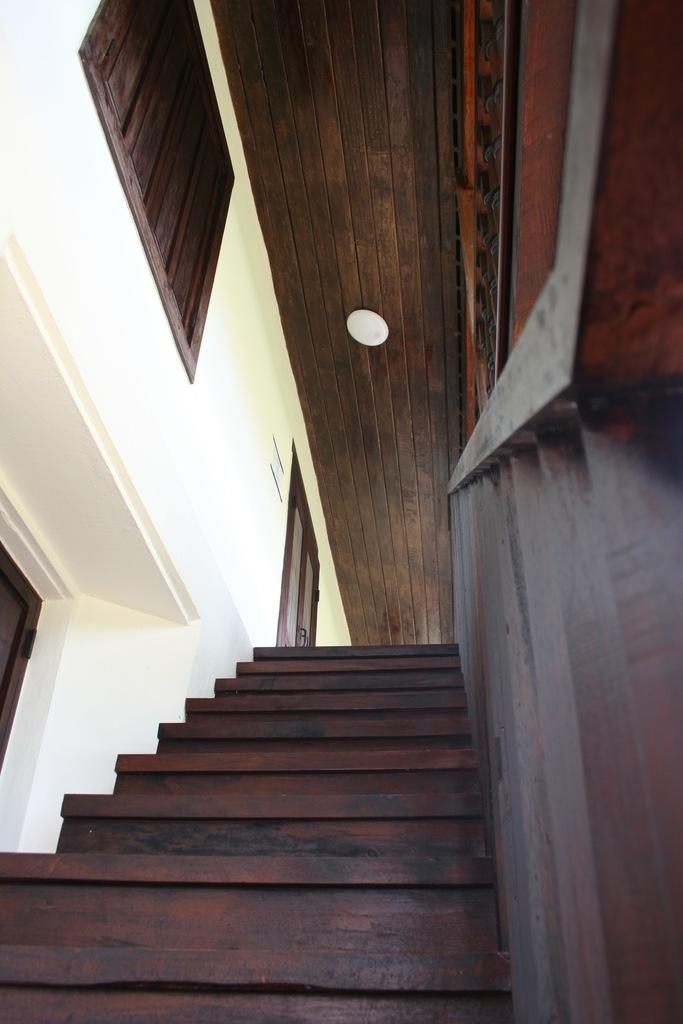What type of structure is present in the image? There is a staircase in the image. What material is used for the railing on the staircase? The railing on the staircase is made of wood. What is visible above the staircase in the image? There is a roof in the image. What surrounds the staircase in the image? There are walls in the image. What type of cracker is being used to hold the staircase together in the image? There is no cracker present in the image, and the staircase does not require any crackers to hold it together. 